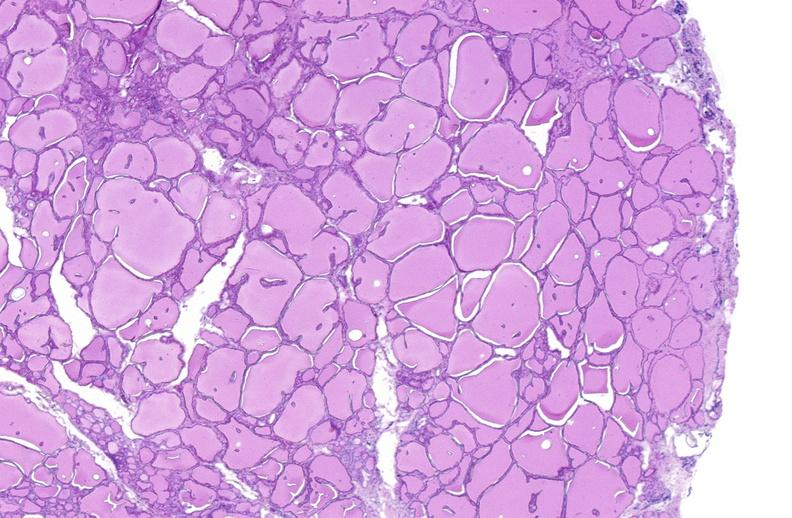what does this image show?
Answer the question using a single word or phrase. Thyroid gland 